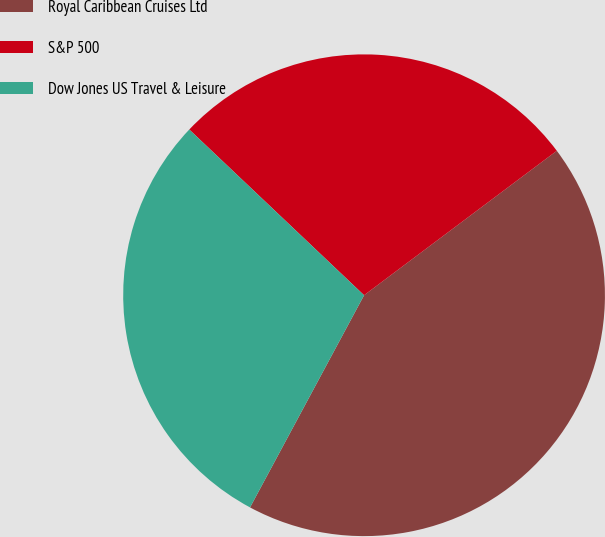<chart> <loc_0><loc_0><loc_500><loc_500><pie_chart><fcel>Royal Caribbean Cruises Ltd<fcel>S&P 500<fcel>Dow Jones US Travel & Leisure<nl><fcel>43.09%<fcel>27.69%<fcel>29.23%<nl></chart> 